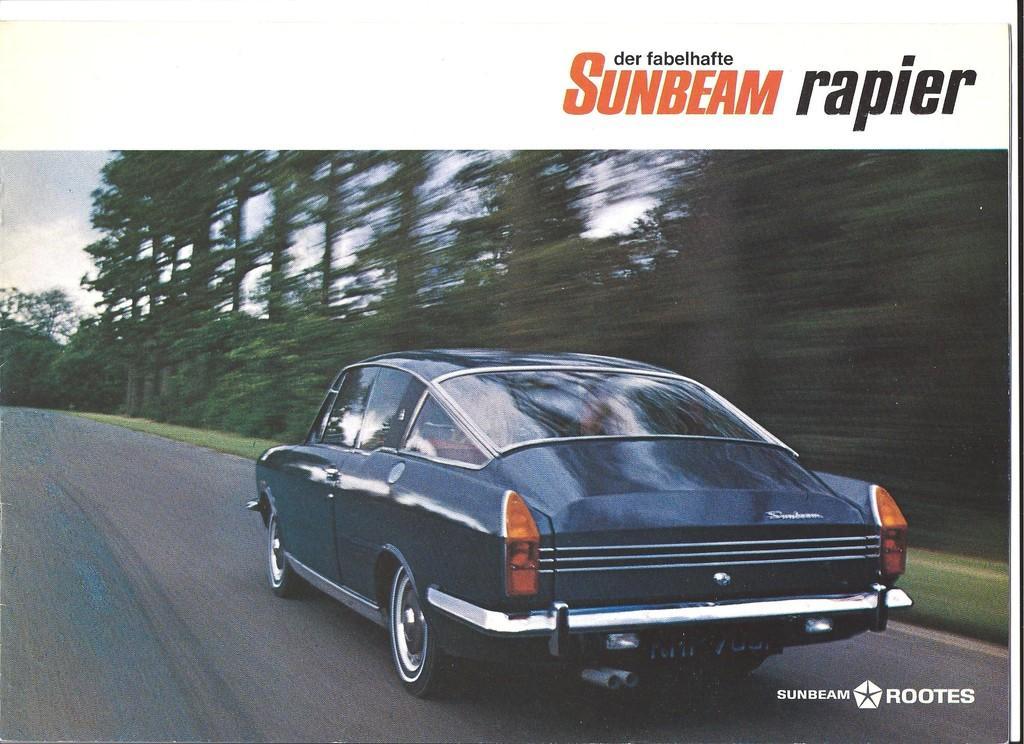Please provide a concise description of this image. In this image there is a fast moving car on the road. In the background there are trees. At the top there is sky. 